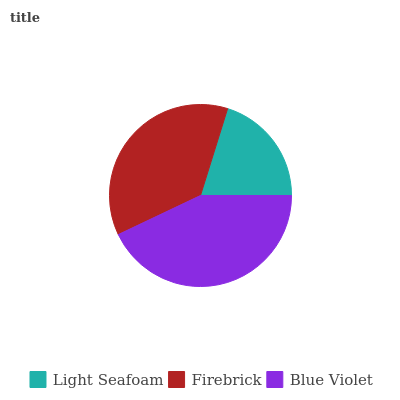Is Light Seafoam the minimum?
Answer yes or no. Yes. Is Blue Violet the maximum?
Answer yes or no. Yes. Is Firebrick the minimum?
Answer yes or no. No. Is Firebrick the maximum?
Answer yes or no. No. Is Firebrick greater than Light Seafoam?
Answer yes or no. Yes. Is Light Seafoam less than Firebrick?
Answer yes or no. Yes. Is Light Seafoam greater than Firebrick?
Answer yes or no. No. Is Firebrick less than Light Seafoam?
Answer yes or no. No. Is Firebrick the high median?
Answer yes or no. Yes. Is Firebrick the low median?
Answer yes or no. Yes. Is Light Seafoam the high median?
Answer yes or no. No. Is Light Seafoam the low median?
Answer yes or no. No. 